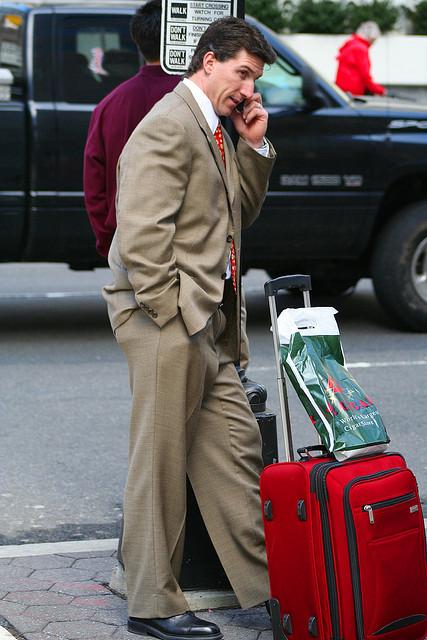What vehicle is shown?
Be succinct. Truck. Is the man talking on the phone?
Concise answer only. Yes. Is that normal airport transportation?
Short answer required. Yes. What is the color of the luggage?
Quick response, please. Red. What is sitting on the ground near his feet?
Quick response, please. Suitcase. What kind of truck is beside the man?
Write a very short answer. Pickup. What is the person doing?
Answer briefly. Talking on phone. What color is the suitcase?
Give a very brief answer. Red. What color is the man in the picture mostly wearing?
Write a very short answer. Tan. What color is his tie?
Be succinct. Red. What color is the bag?
Answer briefly. Red. 